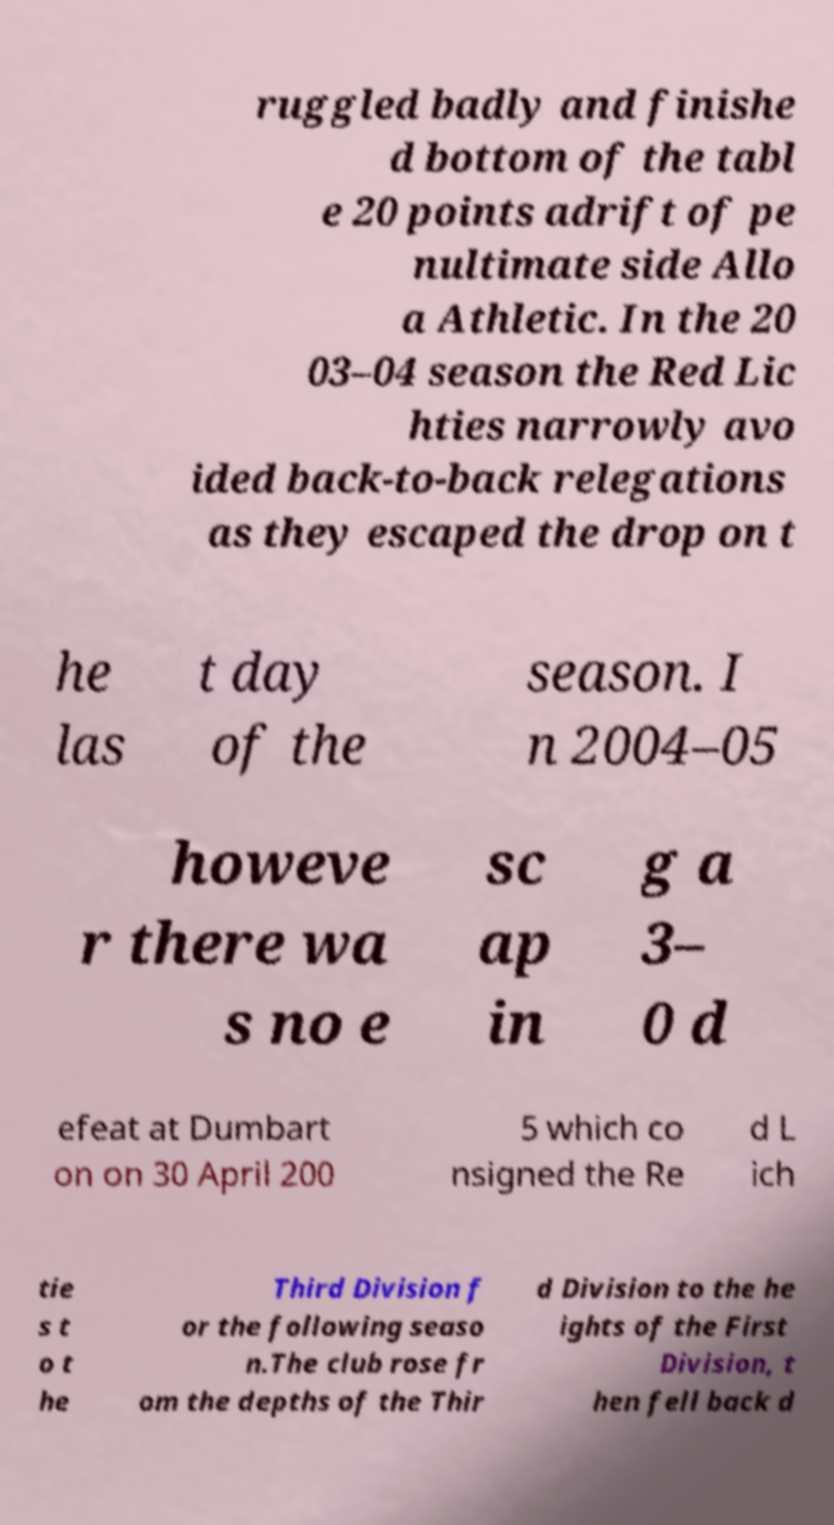There's text embedded in this image that I need extracted. Can you transcribe it verbatim? ruggled badly and finishe d bottom of the tabl e 20 points adrift of pe nultimate side Allo a Athletic. In the 20 03–04 season the Red Lic hties narrowly avo ided back-to-back relegations as they escaped the drop on t he las t day of the season. I n 2004–05 howeve r there wa s no e sc ap in g a 3– 0 d efeat at Dumbart on on 30 April 200 5 which co nsigned the Re d L ich tie s t o t he Third Division f or the following seaso n.The club rose fr om the depths of the Thir d Division to the he ights of the First Division, t hen fell back d 